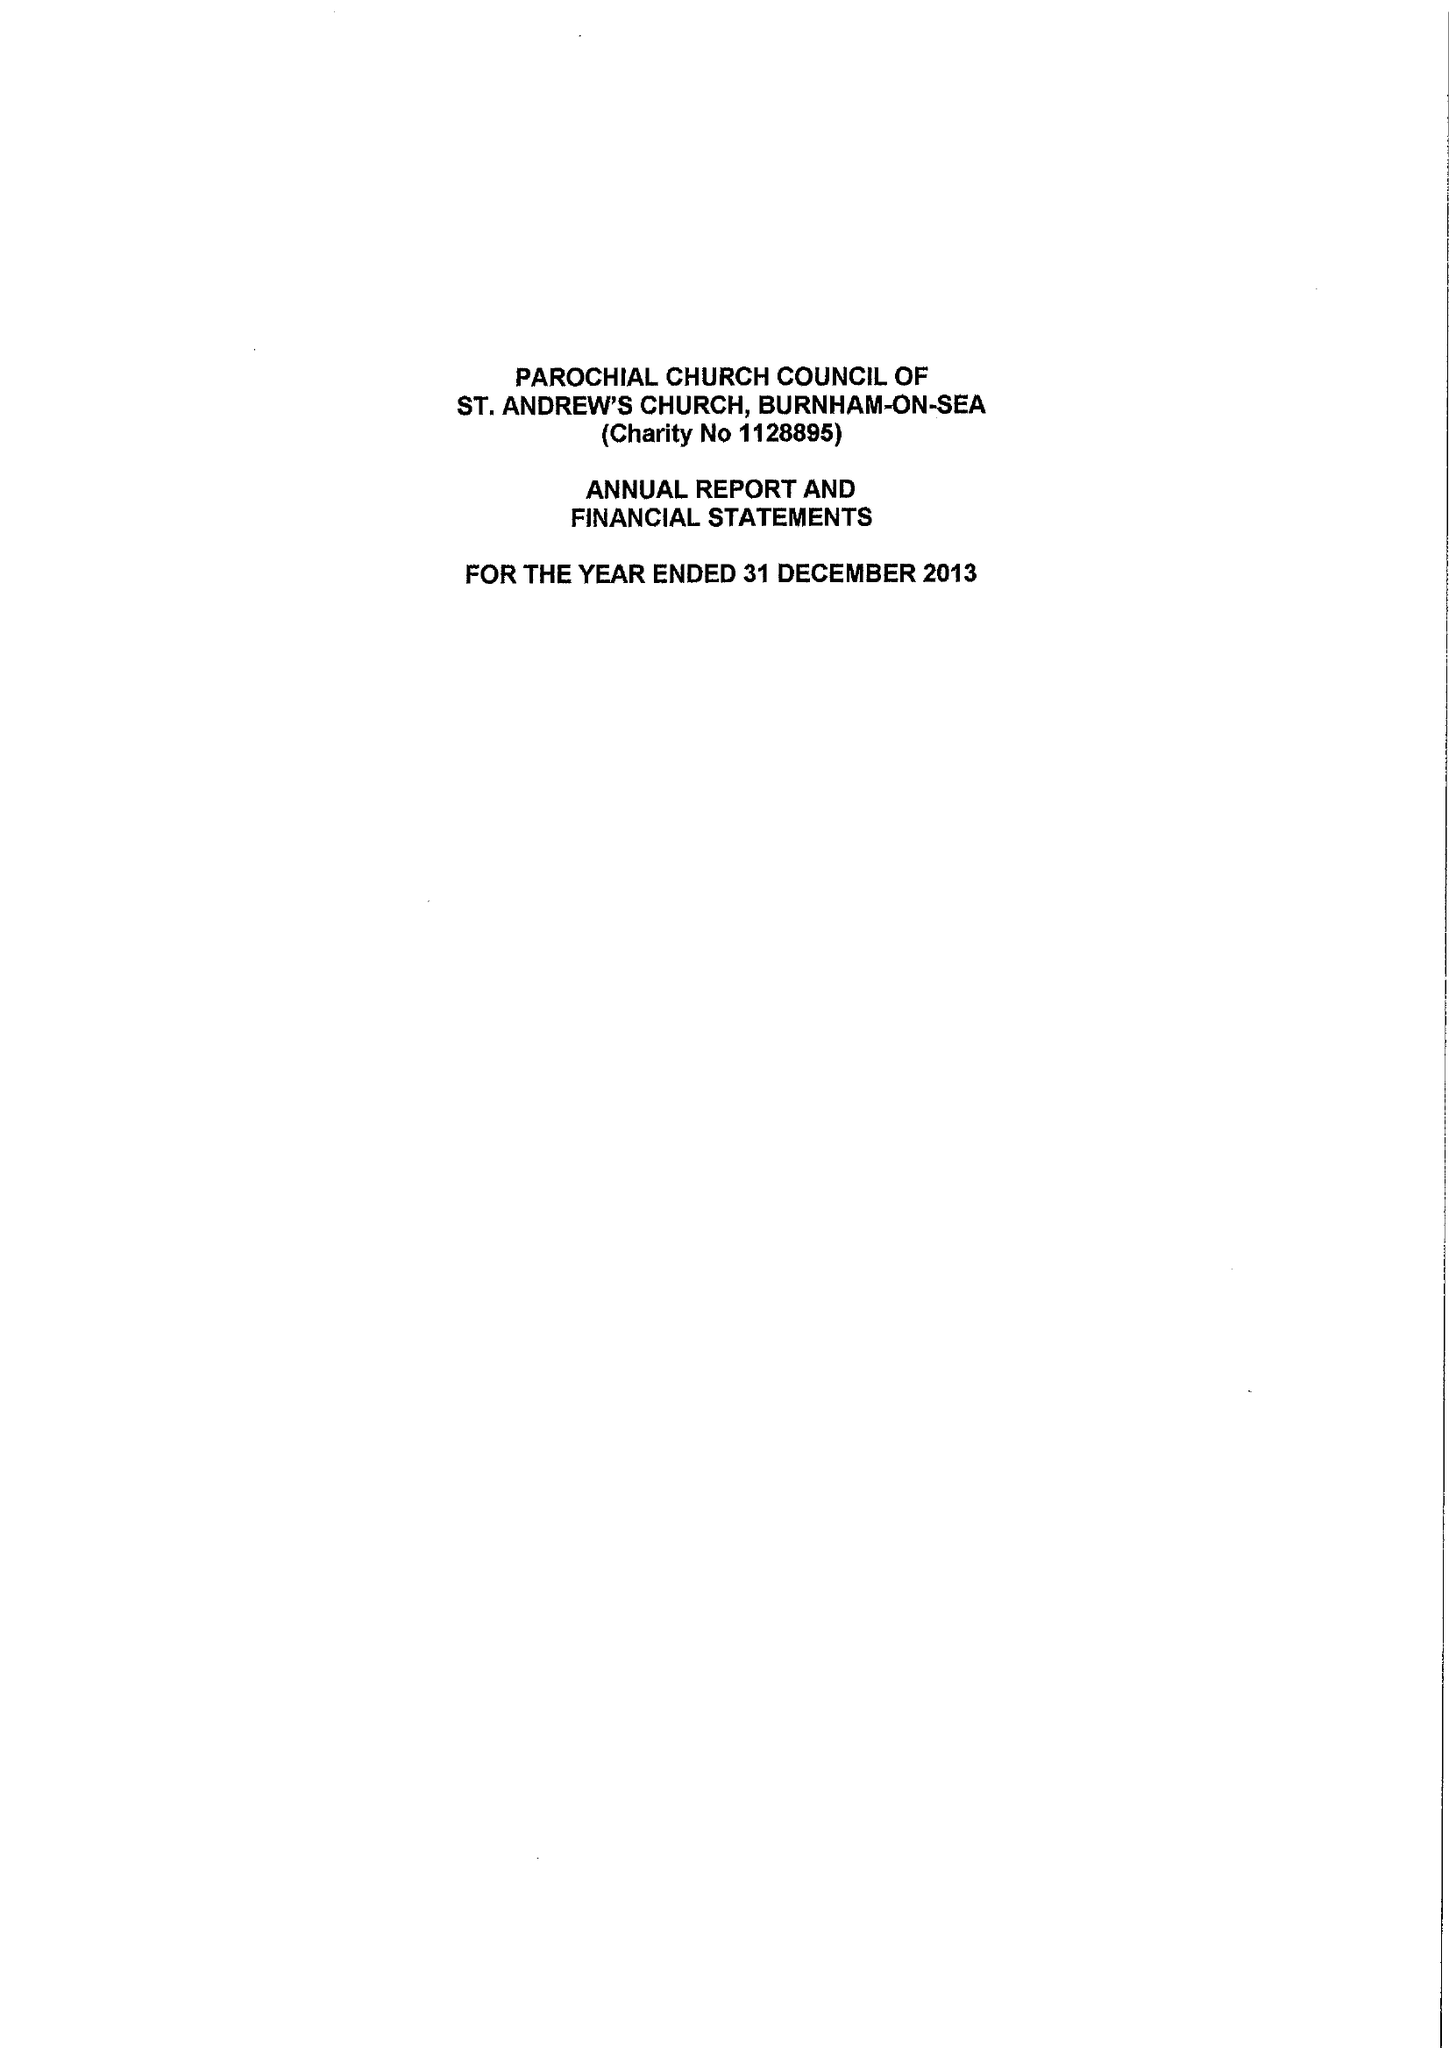What is the value for the address__postcode?
Answer the question using a single word or phrase. TA8 2UL 